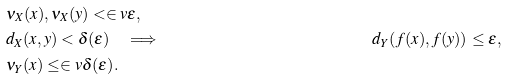Convert formula to latex. <formula><loc_0><loc_0><loc_500><loc_500>& \nu _ { X } ( x ) , \nu _ { X } ( y ) < \in v { \varepsilon } , \\ & d _ { X } ( x , y ) < \delta ( \varepsilon ) \quad \Longrightarrow \quad & d _ { Y } ( f ( x ) , f ( y ) ) \leq \varepsilon , \\ & \nu _ { Y } ( x ) \leq \in v { \delta ( \varepsilon ) } .</formula> 